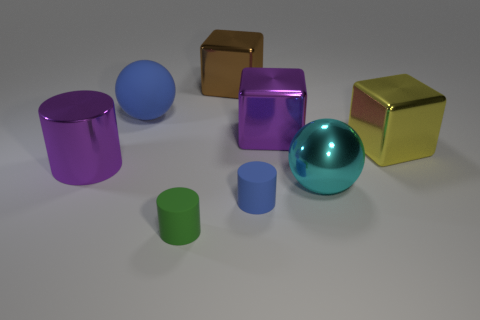What number of gray spheres are there?
Give a very brief answer. 0. Is the cyan metallic object the same size as the metal cylinder?
Offer a very short reply. Yes. How many other things are the same shape as the large blue matte thing?
Ensure brevity in your answer.  1. What is the ball in front of the ball on the left side of the small blue rubber thing made of?
Make the answer very short. Metal. There is a large purple shiny cylinder; are there any cylinders on the right side of it?
Give a very brief answer. Yes. There is a blue matte ball; is it the same size as the yellow shiny block that is behind the large purple cylinder?
Offer a very short reply. Yes. There is another rubber thing that is the same shape as the big cyan object; what is its size?
Your response must be concise. Large. Are there any other things that have the same material as the small blue thing?
Your answer should be very brief. Yes. There is a cylinder that is on the left side of the green cylinder; does it have the same size as the ball behind the big cylinder?
Your response must be concise. Yes. What number of large things are rubber balls or green rubber cylinders?
Offer a very short reply. 1. 